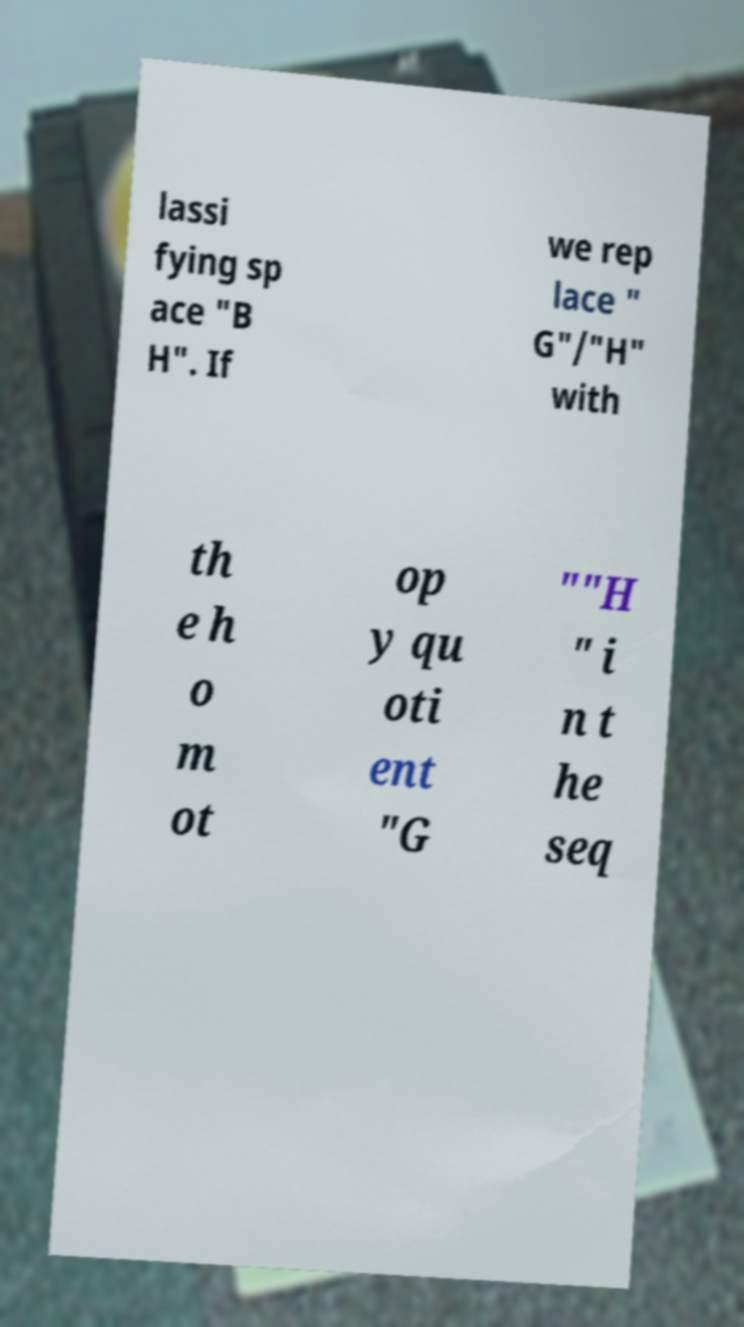Can you read and provide the text displayed in the image?This photo seems to have some interesting text. Can you extract and type it out for me? lassi fying sp ace "B H". If we rep lace " G"/"H" with th e h o m ot op y qu oti ent "G ""H " i n t he seq 